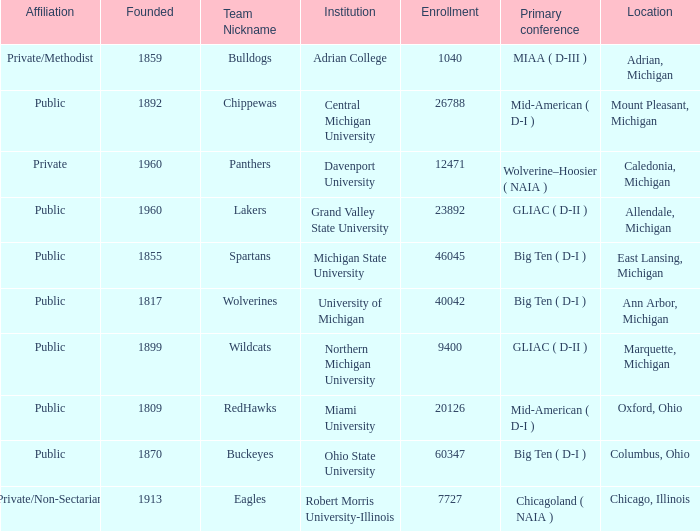How many primary conferences were held in Allendale, Michigan? 1.0. Could you parse the entire table as a dict? {'header': ['Affiliation', 'Founded', 'Team Nickname', 'Institution', 'Enrollment', 'Primary conference', 'Location'], 'rows': [['Private/Methodist', '1859', 'Bulldogs', 'Adrian College', '1040', 'MIAA ( D-III )', 'Adrian, Michigan'], ['Public', '1892', 'Chippewas', 'Central Michigan University', '26788', 'Mid-American ( D-I )', 'Mount Pleasant, Michigan'], ['Private', '1960', 'Panthers', 'Davenport University', '12471', 'Wolverine–Hoosier ( NAIA )', 'Caledonia, Michigan'], ['Public', '1960', 'Lakers', 'Grand Valley State University', '23892', 'GLIAC ( D-II )', 'Allendale, Michigan'], ['Public', '1855', 'Spartans', 'Michigan State University', '46045', 'Big Ten ( D-I )', 'East Lansing, Michigan'], ['Public', '1817', 'Wolverines', 'University of Michigan', '40042', 'Big Ten ( D-I )', 'Ann Arbor, Michigan'], ['Public', '1899', 'Wildcats', 'Northern Michigan University', '9400', 'GLIAC ( D-II )', 'Marquette, Michigan'], ['Public', '1809', 'RedHawks', 'Miami University', '20126', 'Mid-American ( D-I )', 'Oxford, Ohio'], ['Public', '1870', 'Buckeyes', 'Ohio State University', '60347', 'Big Ten ( D-I )', 'Columbus, Ohio'], ['Private/Non-Sectarian', '1913', 'Eagles', 'Robert Morris University-Illinois', '7727', 'Chicagoland ( NAIA )', 'Chicago, Illinois']]} 